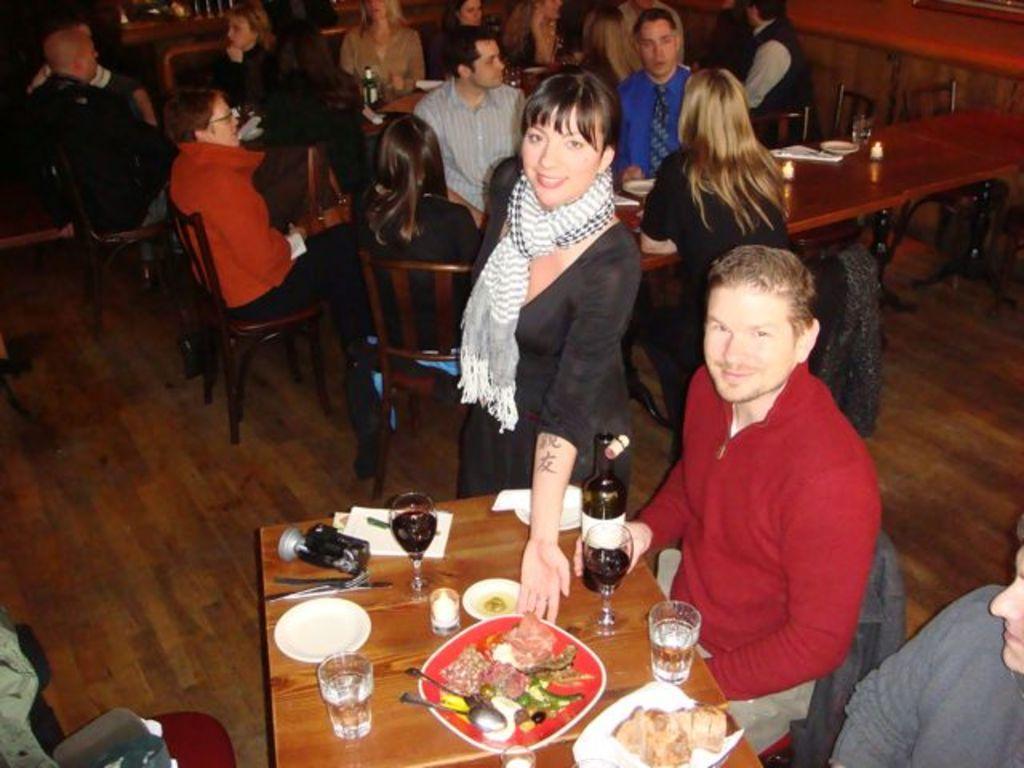Could you give a brief overview of what you see in this image? In this image I can see people where few of them are standing and rest all are sitting. Here on this table I can see few glasses, few spoons, a bottle and food in plates. In the background I can see few more tables. 